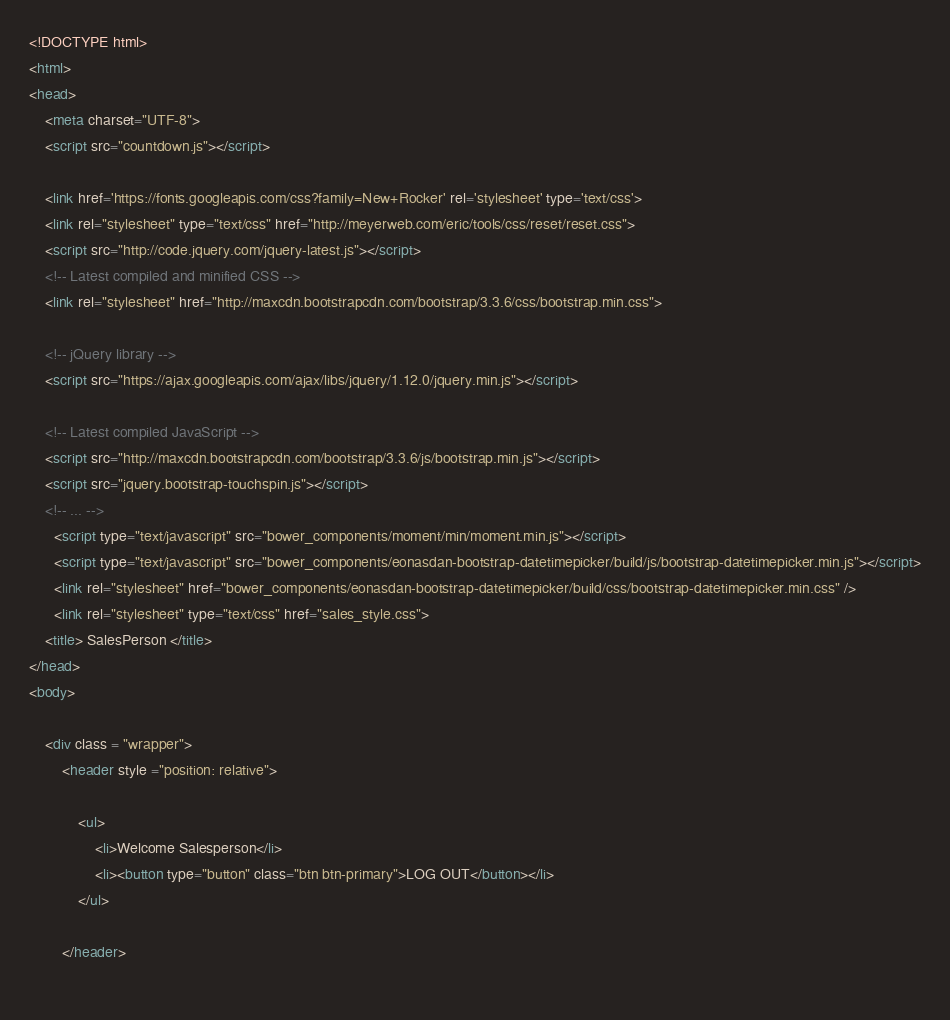<code> <loc_0><loc_0><loc_500><loc_500><_HTML_><!DOCTYPE html>
<html>
<head>
	<meta charset="UTF-8">
	<script src="countdown.js"></script>
	
	<link href='https://fonts.googleapis.com/css?family=New+Rocker' rel='stylesheet' type='text/css'>
	<link rel="stylesheet" type="text/css" href="http://meyerweb.com/eric/tools/css/reset/reset.css">
	<script src="http://code.jquery.com/jquery-latest.js"></script>
	<!-- Latest compiled and minified CSS -->
	<link rel="stylesheet" href="http://maxcdn.bootstrapcdn.com/bootstrap/3.3.6/css/bootstrap.min.css">

	<!-- jQuery library -->
	<script src="https://ajax.googleapis.com/ajax/libs/jquery/1.12.0/jquery.min.js"></script>

	<!-- Latest compiled JavaScript -->
	<script src="http://maxcdn.bootstrapcdn.com/bootstrap/3.3.6/js/bootstrap.min.js"></script>
	<script src="jquery.bootstrap-touchspin.js"></script>
	<!-- ... -->
	  <script type="text/javascript" src="bower_components/moment/min/moment.min.js"></script>
	  <script type="text/javascript" src="bower_components/eonasdan-bootstrap-datetimepicker/build/js/bootstrap-datetimepicker.min.js"></script>
	  <link rel="stylesheet" href="bower_components/eonasdan-bootstrap-datetimepicker/build/css/bootstrap-datetimepicker.min.css" />
	  <link rel="stylesheet" type="text/css" href="sales_style.css">
	<title> SalesPerson </title>
</head>
<body>
	
	<div class = "wrapper">
		<header style ="position: relative">
		
			<ul>
				<li>Welcome Salesperson</li>
				<li><button type="button" class="btn btn-primary">LOG OUT</button></li>
			</ul>
	
		</header>		
		
</code> 